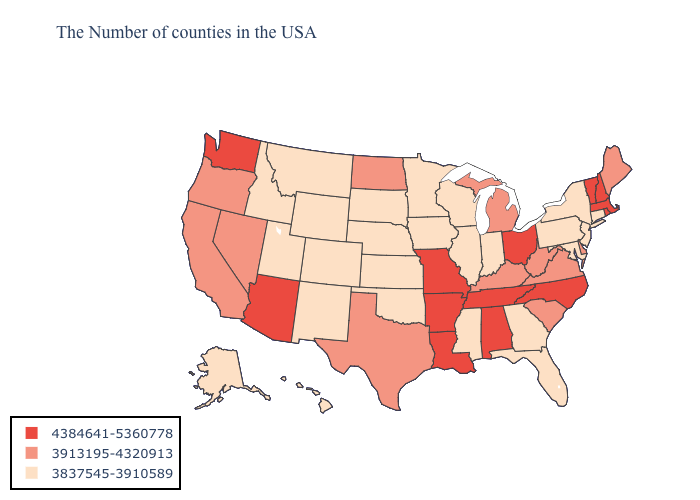Name the states that have a value in the range 3837545-3910589?
Quick response, please. Connecticut, New York, New Jersey, Maryland, Pennsylvania, Florida, Georgia, Indiana, Wisconsin, Illinois, Mississippi, Minnesota, Iowa, Kansas, Nebraska, Oklahoma, South Dakota, Wyoming, Colorado, New Mexico, Utah, Montana, Idaho, Alaska, Hawaii. Which states have the lowest value in the Northeast?
Concise answer only. Connecticut, New York, New Jersey, Pennsylvania. Name the states that have a value in the range 4384641-5360778?
Give a very brief answer. Massachusetts, Rhode Island, New Hampshire, Vermont, North Carolina, Ohio, Alabama, Tennessee, Louisiana, Missouri, Arkansas, Arizona, Washington. Which states hav the highest value in the Northeast?
Quick response, please. Massachusetts, Rhode Island, New Hampshire, Vermont. Which states hav the highest value in the MidWest?
Keep it brief. Ohio, Missouri. What is the value of Illinois?
Keep it brief. 3837545-3910589. Which states have the highest value in the USA?
Be succinct. Massachusetts, Rhode Island, New Hampshire, Vermont, North Carolina, Ohio, Alabama, Tennessee, Louisiana, Missouri, Arkansas, Arizona, Washington. Name the states that have a value in the range 3837545-3910589?
Keep it brief. Connecticut, New York, New Jersey, Maryland, Pennsylvania, Florida, Georgia, Indiana, Wisconsin, Illinois, Mississippi, Minnesota, Iowa, Kansas, Nebraska, Oklahoma, South Dakota, Wyoming, Colorado, New Mexico, Utah, Montana, Idaho, Alaska, Hawaii. Among the states that border South Carolina , which have the lowest value?
Answer briefly. Georgia. Among the states that border Alabama , which have the highest value?
Give a very brief answer. Tennessee. Among the states that border New York , which have the lowest value?
Short answer required. Connecticut, New Jersey, Pennsylvania. Which states have the lowest value in the South?
Quick response, please. Maryland, Florida, Georgia, Mississippi, Oklahoma. Does South Dakota have a lower value than Vermont?
Short answer required. Yes. Which states hav the highest value in the MidWest?
Give a very brief answer. Ohio, Missouri. Does Rhode Island have the highest value in the Northeast?
Keep it brief. Yes. 